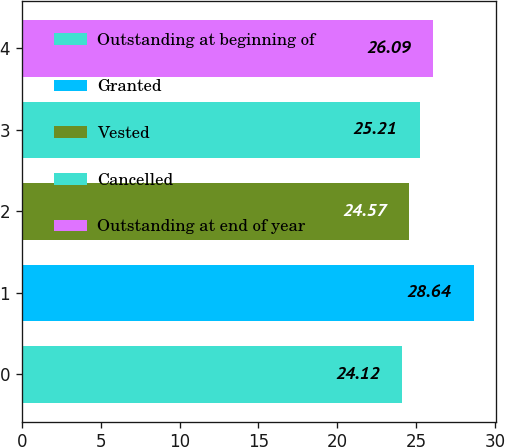<chart> <loc_0><loc_0><loc_500><loc_500><bar_chart><fcel>Outstanding at beginning of<fcel>Granted<fcel>Vested<fcel>Cancelled<fcel>Outstanding at end of year<nl><fcel>24.12<fcel>28.64<fcel>24.57<fcel>25.21<fcel>26.09<nl></chart> 